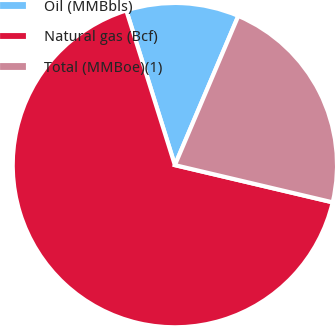Convert chart. <chart><loc_0><loc_0><loc_500><loc_500><pie_chart><fcel>Oil (MMBbls)<fcel>Natural gas (Bcf)<fcel>Total (MMBoe)(1)<nl><fcel>11.24%<fcel>66.47%<fcel>22.29%<nl></chart> 